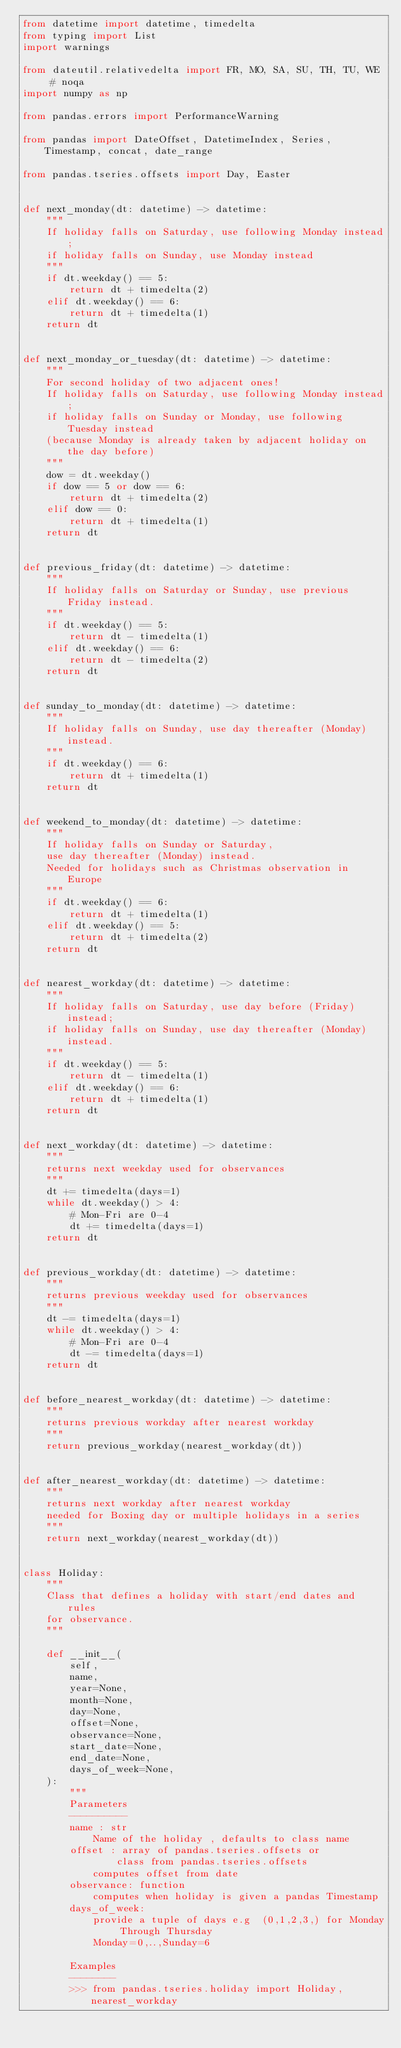<code> <loc_0><loc_0><loc_500><loc_500><_Python_>from datetime import datetime, timedelta
from typing import List
import warnings

from dateutil.relativedelta import FR, MO, SA, SU, TH, TU, WE  # noqa
import numpy as np

from pandas.errors import PerformanceWarning

from pandas import DateOffset, DatetimeIndex, Series, Timestamp, concat, date_range

from pandas.tseries.offsets import Day, Easter


def next_monday(dt: datetime) -> datetime:
    """
    If holiday falls on Saturday, use following Monday instead;
    if holiday falls on Sunday, use Monday instead
    """
    if dt.weekday() == 5:
        return dt + timedelta(2)
    elif dt.weekday() == 6:
        return dt + timedelta(1)
    return dt


def next_monday_or_tuesday(dt: datetime) -> datetime:
    """
    For second holiday of two adjacent ones!
    If holiday falls on Saturday, use following Monday instead;
    if holiday falls on Sunday or Monday, use following Tuesday instead
    (because Monday is already taken by adjacent holiday on the day before)
    """
    dow = dt.weekday()
    if dow == 5 or dow == 6:
        return dt + timedelta(2)
    elif dow == 0:
        return dt + timedelta(1)
    return dt


def previous_friday(dt: datetime) -> datetime:
    """
    If holiday falls on Saturday or Sunday, use previous Friday instead.
    """
    if dt.weekday() == 5:
        return dt - timedelta(1)
    elif dt.weekday() == 6:
        return dt - timedelta(2)
    return dt


def sunday_to_monday(dt: datetime) -> datetime:
    """
    If holiday falls on Sunday, use day thereafter (Monday) instead.
    """
    if dt.weekday() == 6:
        return dt + timedelta(1)
    return dt


def weekend_to_monday(dt: datetime) -> datetime:
    """
    If holiday falls on Sunday or Saturday,
    use day thereafter (Monday) instead.
    Needed for holidays such as Christmas observation in Europe
    """
    if dt.weekday() == 6:
        return dt + timedelta(1)
    elif dt.weekday() == 5:
        return dt + timedelta(2)
    return dt


def nearest_workday(dt: datetime) -> datetime:
    """
    If holiday falls on Saturday, use day before (Friday) instead;
    if holiday falls on Sunday, use day thereafter (Monday) instead.
    """
    if dt.weekday() == 5:
        return dt - timedelta(1)
    elif dt.weekday() == 6:
        return dt + timedelta(1)
    return dt


def next_workday(dt: datetime) -> datetime:
    """
    returns next weekday used for observances
    """
    dt += timedelta(days=1)
    while dt.weekday() > 4:
        # Mon-Fri are 0-4
        dt += timedelta(days=1)
    return dt


def previous_workday(dt: datetime) -> datetime:
    """
    returns previous weekday used for observances
    """
    dt -= timedelta(days=1)
    while dt.weekday() > 4:
        # Mon-Fri are 0-4
        dt -= timedelta(days=1)
    return dt


def before_nearest_workday(dt: datetime) -> datetime:
    """
    returns previous workday after nearest workday
    """
    return previous_workday(nearest_workday(dt))


def after_nearest_workday(dt: datetime) -> datetime:
    """
    returns next workday after nearest workday
    needed for Boxing day or multiple holidays in a series
    """
    return next_workday(nearest_workday(dt))


class Holiday:
    """
    Class that defines a holiday with start/end dates and rules
    for observance.
    """

    def __init__(
        self,
        name,
        year=None,
        month=None,
        day=None,
        offset=None,
        observance=None,
        start_date=None,
        end_date=None,
        days_of_week=None,
    ):
        """
        Parameters
        ----------
        name : str
            Name of the holiday , defaults to class name
        offset : array of pandas.tseries.offsets or
                class from pandas.tseries.offsets
            computes offset from date
        observance: function
            computes when holiday is given a pandas Timestamp
        days_of_week:
            provide a tuple of days e.g  (0,1,2,3,) for Monday Through Thursday
            Monday=0,..,Sunday=6

        Examples
        --------
        >>> from pandas.tseries.holiday import Holiday, nearest_workday</code> 